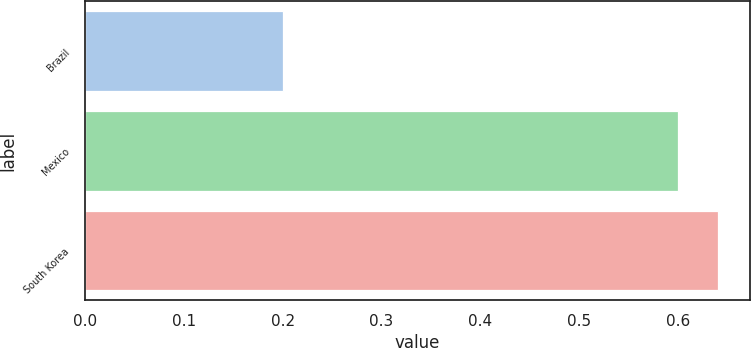Convert chart to OTSL. <chart><loc_0><loc_0><loc_500><loc_500><bar_chart><fcel>Brazil<fcel>Mexico<fcel>South Korea<nl><fcel>0.2<fcel>0.6<fcel>0.64<nl></chart> 